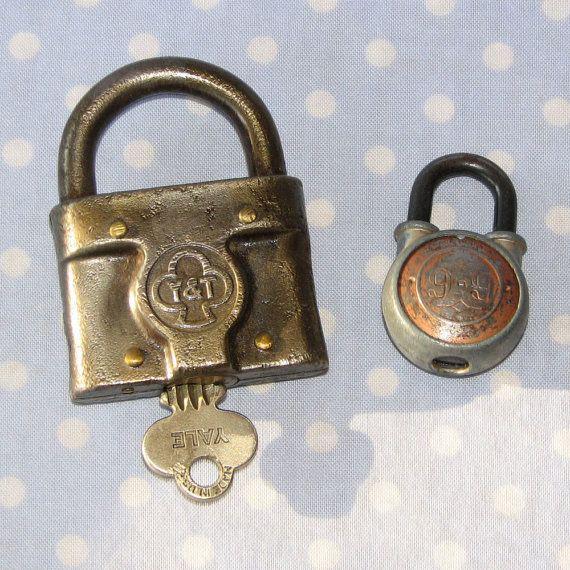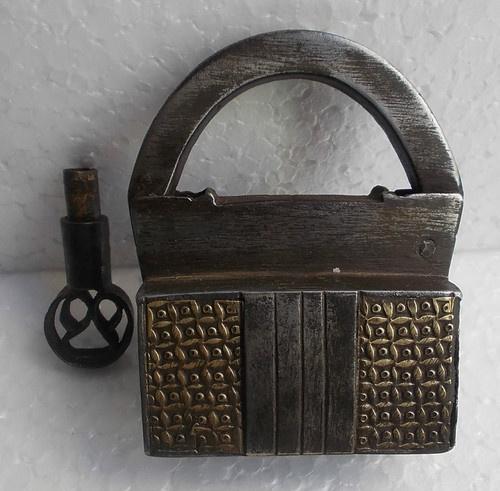The first image is the image on the left, the second image is the image on the right. Evaluate the accuracy of this statement regarding the images: "One image shows three antique padlocks with keyholes visible on the lower front panel of the padlock, with keys displayed in front of them.". Is it true? Answer yes or no. No. The first image is the image on the left, the second image is the image on the right. Given the left and right images, does the statement "There are three padlocks in total." hold true? Answer yes or no. Yes. 